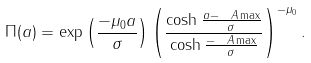<formula> <loc_0><loc_0><loc_500><loc_500>\Pi ( a ) = \exp \left ( \frac { - \mu _ { 0 } a } { \sigma } \right ) \left ( \frac { \cosh \frac { a - \ A \max } { \sigma } } { \cosh \frac { - \ A \max } { \sigma } } \right ) ^ { - \mu _ { 0 } } .</formula> 